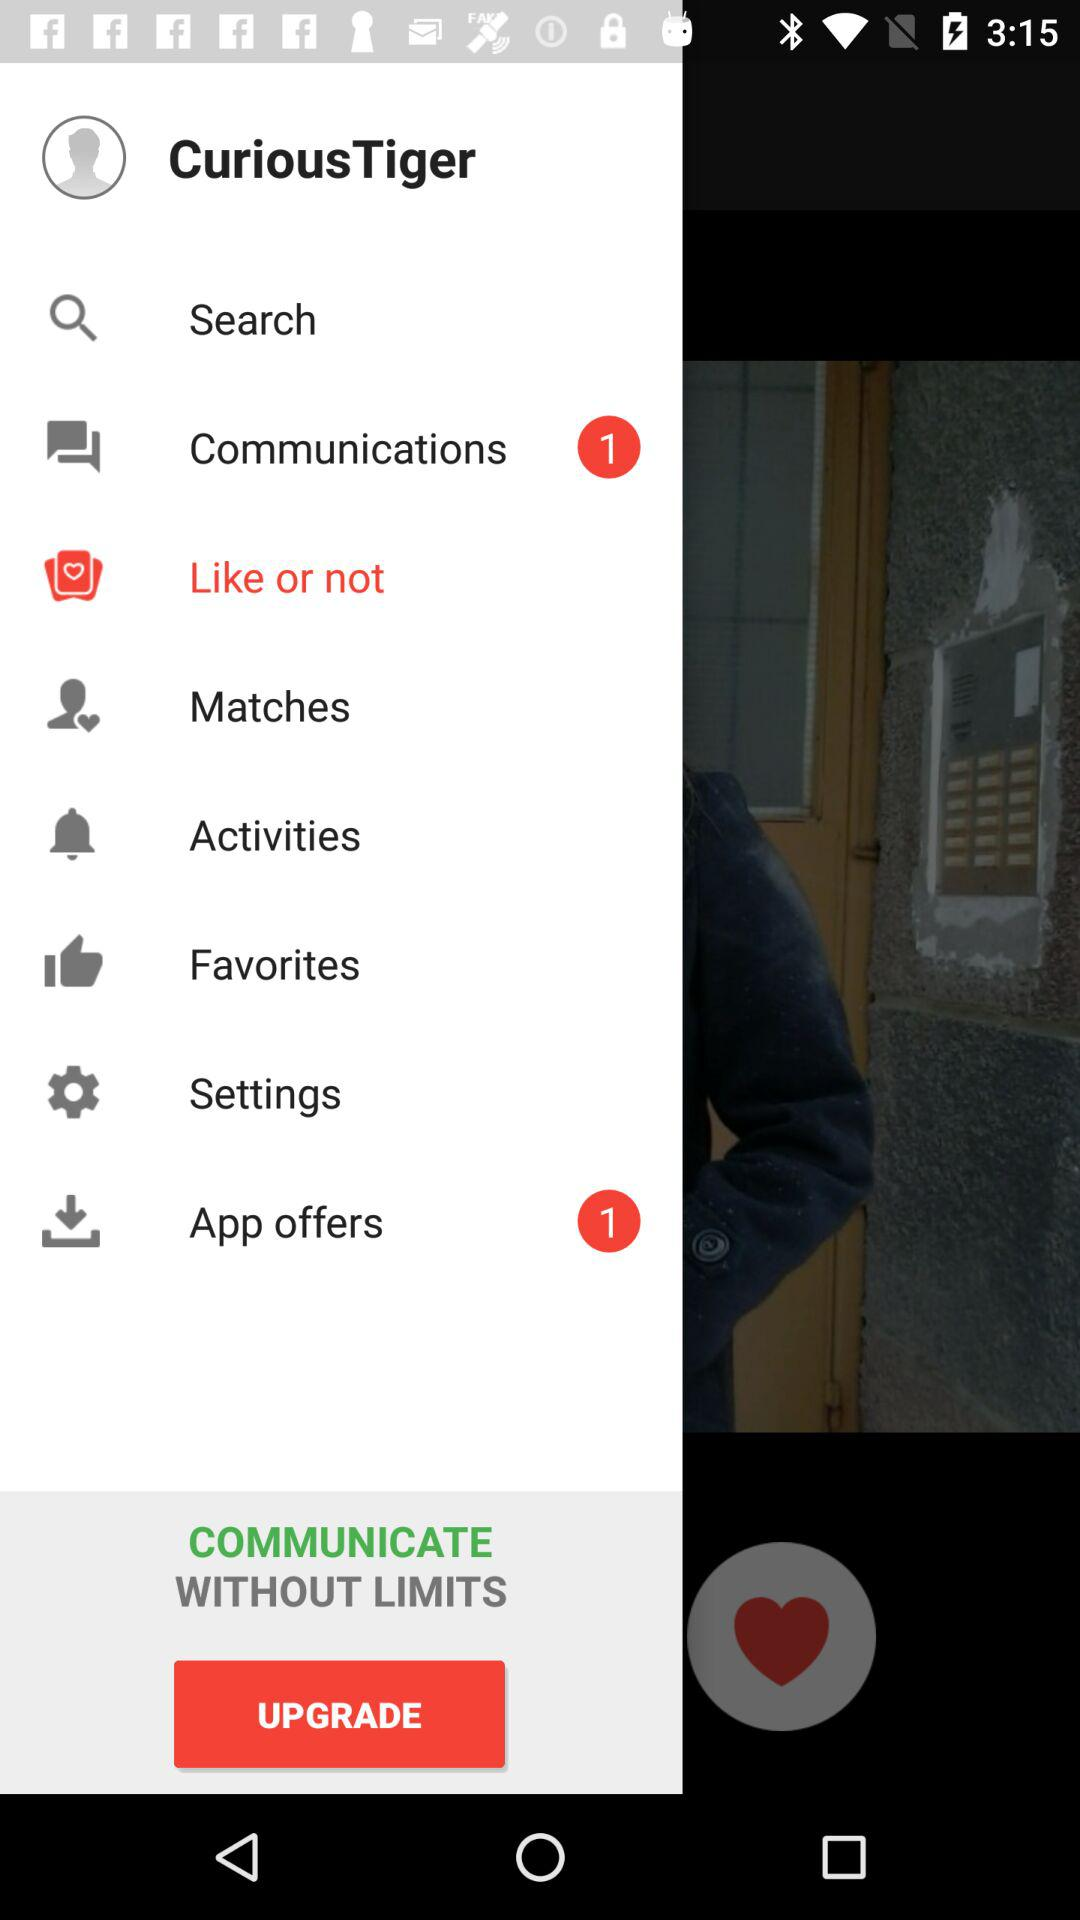How many application offers are there? There is 1 application offer. 